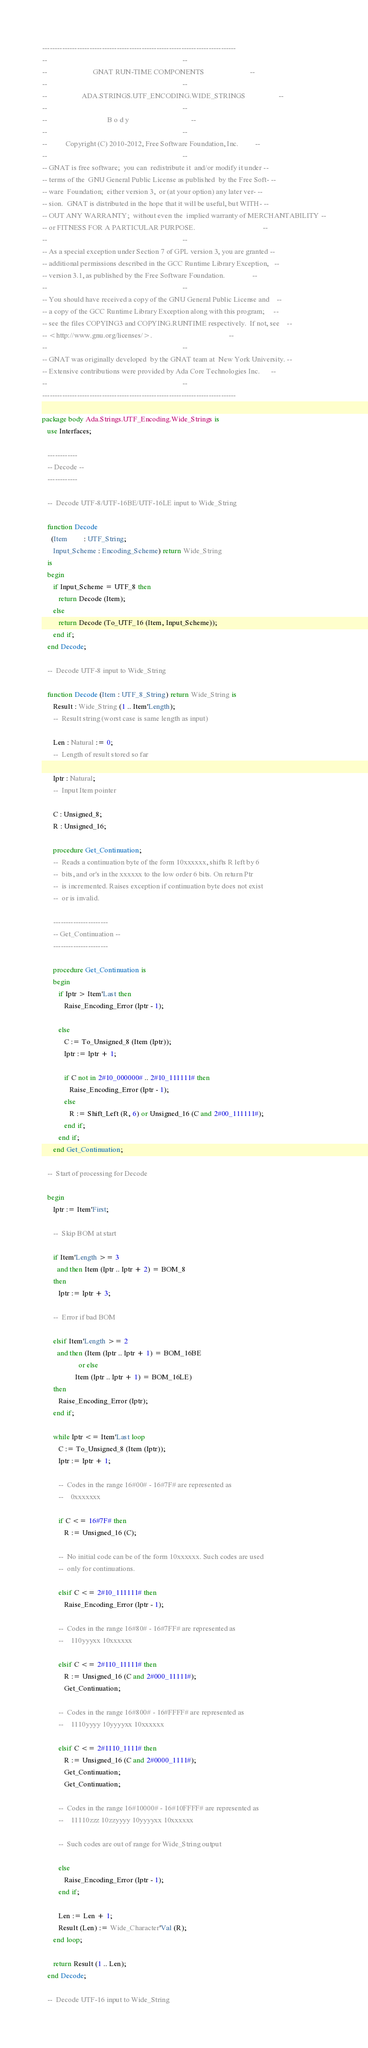<code> <loc_0><loc_0><loc_500><loc_500><_Ada_>------------------------------------------------------------------------------
--                                                                          --
--                         GNAT RUN-TIME COMPONENTS                         --
--                                                                          --
--                   ADA.STRINGS.UTF_ENCODING.WIDE_STRINGS                  --
--                                                                          --
--                                 B o d y                                  --
--                                                                          --
--          Copyright (C) 2010-2012, Free Software Foundation, Inc.         --
--                                                                          --
-- GNAT is free software;  you can  redistribute it  and/or modify it under --
-- terms of the  GNU General Public License as published  by the Free Soft- --
-- ware  Foundation;  either version 3,  or (at your option) any later ver- --
-- sion.  GNAT is distributed in the hope that it will be useful, but WITH- --
-- OUT ANY WARRANTY;  without even the  implied warranty of MERCHANTABILITY --
-- or FITNESS FOR A PARTICULAR PURPOSE.                                     --
--                                                                          --
-- As a special exception under Section 7 of GPL version 3, you are granted --
-- additional permissions described in the GCC Runtime Library Exception,   --
-- version 3.1, as published by the Free Software Foundation.               --
--                                                                          --
-- You should have received a copy of the GNU General Public License and    --
-- a copy of the GCC Runtime Library Exception along with this program;     --
-- see the files COPYING3 and COPYING.RUNTIME respectively.  If not, see    --
-- <http://www.gnu.org/licenses/>.                                          --
--                                                                          --
-- GNAT was originally developed  by the GNAT team at  New York University. --
-- Extensive contributions were provided by Ada Core Technologies Inc.      --
--                                                                          --
------------------------------------------------------------------------------

package body Ada.Strings.UTF_Encoding.Wide_Strings is
   use Interfaces;

   ------------
   -- Decode --
   ------------

   --  Decode UTF-8/UTF-16BE/UTF-16LE input to Wide_String

   function Decode
     (Item         : UTF_String;
      Input_Scheme : Encoding_Scheme) return Wide_String
   is
   begin
      if Input_Scheme = UTF_8 then
         return Decode (Item);
      else
         return Decode (To_UTF_16 (Item, Input_Scheme));
      end if;
   end Decode;

   --  Decode UTF-8 input to Wide_String

   function Decode (Item : UTF_8_String) return Wide_String is
      Result : Wide_String (1 .. Item'Length);
      --  Result string (worst case is same length as input)

      Len : Natural := 0;
      --  Length of result stored so far

      Iptr : Natural;
      --  Input Item pointer

      C : Unsigned_8;
      R : Unsigned_16;

      procedure Get_Continuation;
      --  Reads a continuation byte of the form 10xxxxxx, shifts R left by 6
      --  bits, and or's in the xxxxxx to the low order 6 bits. On return Ptr
      --  is incremented. Raises exception if continuation byte does not exist
      --  or is invalid.

      ----------------------
      -- Get_Continuation --
      ----------------------

      procedure Get_Continuation is
      begin
         if Iptr > Item'Last then
            Raise_Encoding_Error (Iptr - 1);

         else
            C := To_Unsigned_8 (Item (Iptr));
            Iptr := Iptr + 1;

            if C not in 2#10_000000# .. 2#10_111111# then
               Raise_Encoding_Error (Iptr - 1);
            else
               R := Shift_Left (R, 6) or Unsigned_16 (C and 2#00_111111#);
            end if;
         end if;
      end Get_Continuation;

   --  Start of processing for Decode

   begin
      Iptr := Item'First;

      --  Skip BOM at start

      if Item'Length >= 3
        and then Item (Iptr .. Iptr + 2) = BOM_8
      then
         Iptr := Iptr + 3;

      --  Error if bad BOM

      elsif Item'Length >= 2
        and then (Item (Iptr .. Iptr + 1) = BOM_16BE
                    or else
                  Item (Iptr .. Iptr + 1) = BOM_16LE)
      then
         Raise_Encoding_Error (Iptr);
      end if;

      while Iptr <= Item'Last loop
         C := To_Unsigned_8 (Item (Iptr));
         Iptr := Iptr + 1;

         --  Codes in the range 16#00# - 16#7F# are represented as
         --    0xxxxxxx

         if C <= 16#7F# then
            R := Unsigned_16 (C);

         --  No initial code can be of the form 10xxxxxx. Such codes are used
         --  only for continuations.

         elsif C <= 2#10_111111# then
            Raise_Encoding_Error (Iptr - 1);

         --  Codes in the range 16#80# - 16#7FF# are represented as
         --    110yyyxx 10xxxxxx

         elsif C <= 2#110_11111# then
            R := Unsigned_16 (C and 2#000_11111#);
            Get_Continuation;

         --  Codes in the range 16#800# - 16#FFFF# are represented as
         --    1110yyyy 10yyyyxx 10xxxxxx

         elsif C <= 2#1110_1111# then
            R := Unsigned_16 (C and 2#0000_1111#);
            Get_Continuation;
            Get_Continuation;

         --  Codes in the range 16#10000# - 16#10FFFF# are represented as
         --    11110zzz 10zzyyyy 10yyyyxx 10xxxxxx

         --  Such codes are out of range for Wide_String output

         else
            Raise_Encoding_Error (Iptr - 1);
         end if;

         Len := Len + 1;
         Result (Len) := Wide_Character'Val (R);
      end loop;

      return Result (1 .. Len);
   end Decode;

   --  Decode UTF-16 input to Wide_String
</code> 